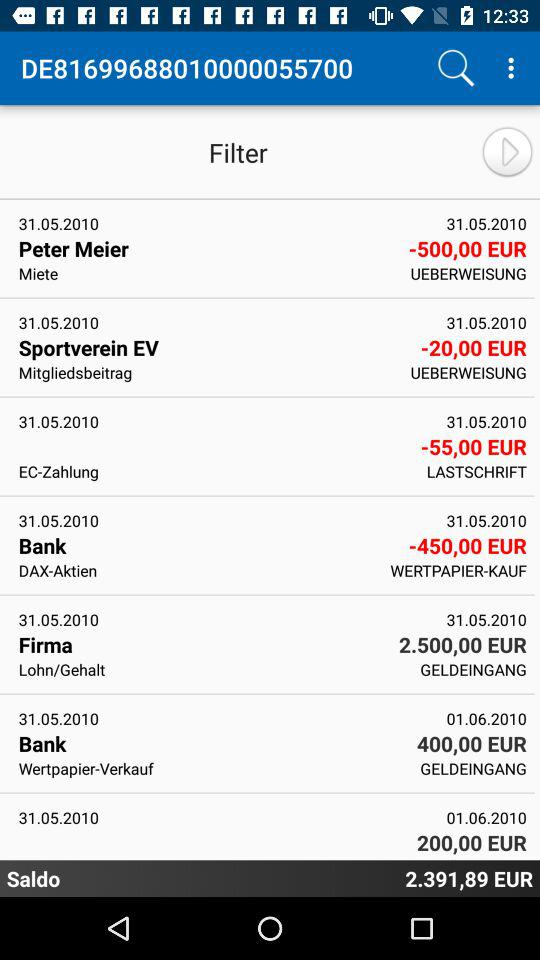What is the saldo? The saldo is 2.391,89 euros. 